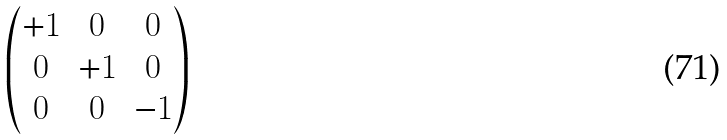<formula> <loc_0><loc_0><loc_500><loc_500>\begin{pmatrix} + 1 & 0 & 0 \\ 0 & + 1 & 0 \\ 0 & 0 & - 1 \\ \end{pmatrix}</formula> 